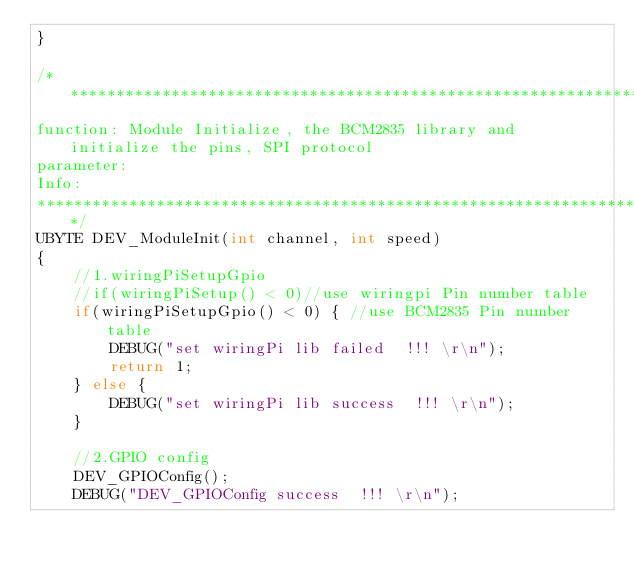Convert code to text. <code><loc_0><loc_0><loc_500><loc_500><_C_>}

/******************************************************************************
function:	Module Initialize, the BCM2835 library and initialize the pins, SPI protocol
parameter:
Info:
******************************************************************************/
UBYTE DEV_ModuleInit(int channel, int speed)
{
    //1.wiringPiSetupGpio
    //if(wiringPiSetup() < 0)//use wiringpi Pin number table
    if(wiringPiSetupGpio() < 0) { //use BCM2835 Pin number table
        DEBUG("set wiringPi lib failed	!!! \r\n");
        return 1;
    } else {
        DEBUG("set wiringPi lib success  !!! \r\n");
    }

    //2.GPIO config
    DEV_GPIOConfig();
    DEBUG("DEV_GPIOConfig success  !!! \r\n");
</code> 